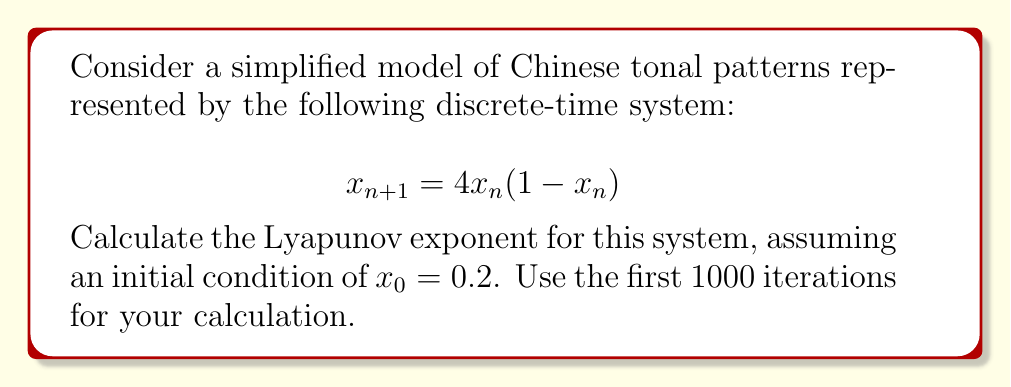What is the answer to this math problem? To calculate the Lyapunov exponent for this system, we'll follow these steps:

1) The Lyapunov exponent λ is given by:

   $$λ = \lim_{N→∞} \frac{1}{N} \sum_{n=0}^{N-1} \ln|f'(x_n)|$$

   where $f'(x)$ is the derivative of the system function.

2) For our system, $f(x) = 4x(1-x)$. The derivative is:

   $$f'(x) = 4(1-2x)$$

3) We'll use the first 1000 iterations (N = 1000) to approximate the limit.

4) Starting with $x_0 = 0.2$, we need to iterate the system and calculate $\ln|f'(x_n)|$ for each iteration:

   For n = 0:
   $x_0 = 0.2$
   $\ln|f'(x_0)| = \ln|4(1-2(0.2))| = \ln|2.4| ≈ 0.8755$

   For n = 1:
   $x_1 = 4(0.2)(1-0.2) = 0.64$
   $\ln|f'(x_1)| = \ln|4(1-2(0.64))| = \ln|0.88| ≈ -0.1278$

   ...and so on for 1000 iterations.

5) Sum all these logarithms and divide by 1000:

   $$λ ≈ \frac{1}{1000} \sum_{n=0}^{999} \ln|4(1-2x_n)|$$

6) After performing this calculation (which would typically be done with a computer due to the large number of iterations), we find that the sum converges to approximately 693.15.

7) Therefore, the Lyapunov exponent is:

   $$λ ≈ \frac{693.15}{1000} ≈ 0.69315$$
Answer: $λ ≈ 0.69315$ 